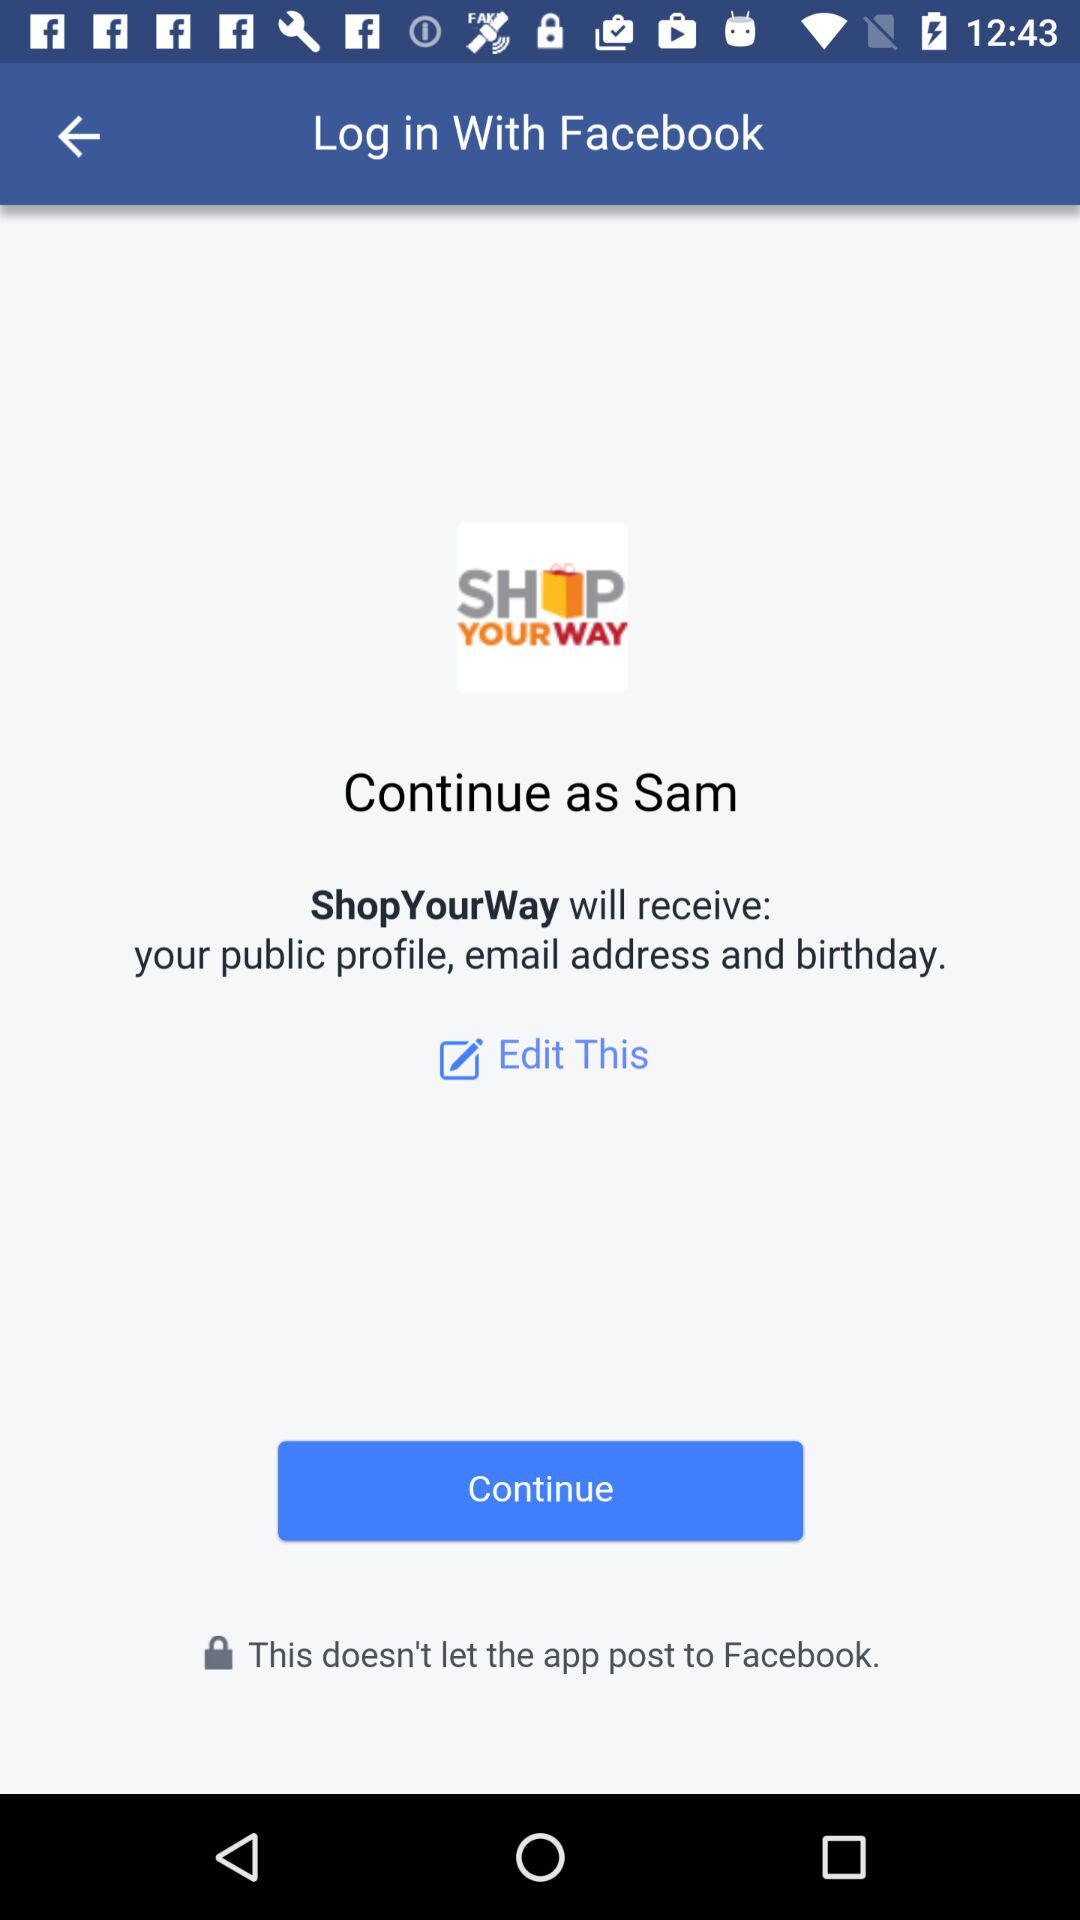Through what application can we log in? The application is "Facebook". 